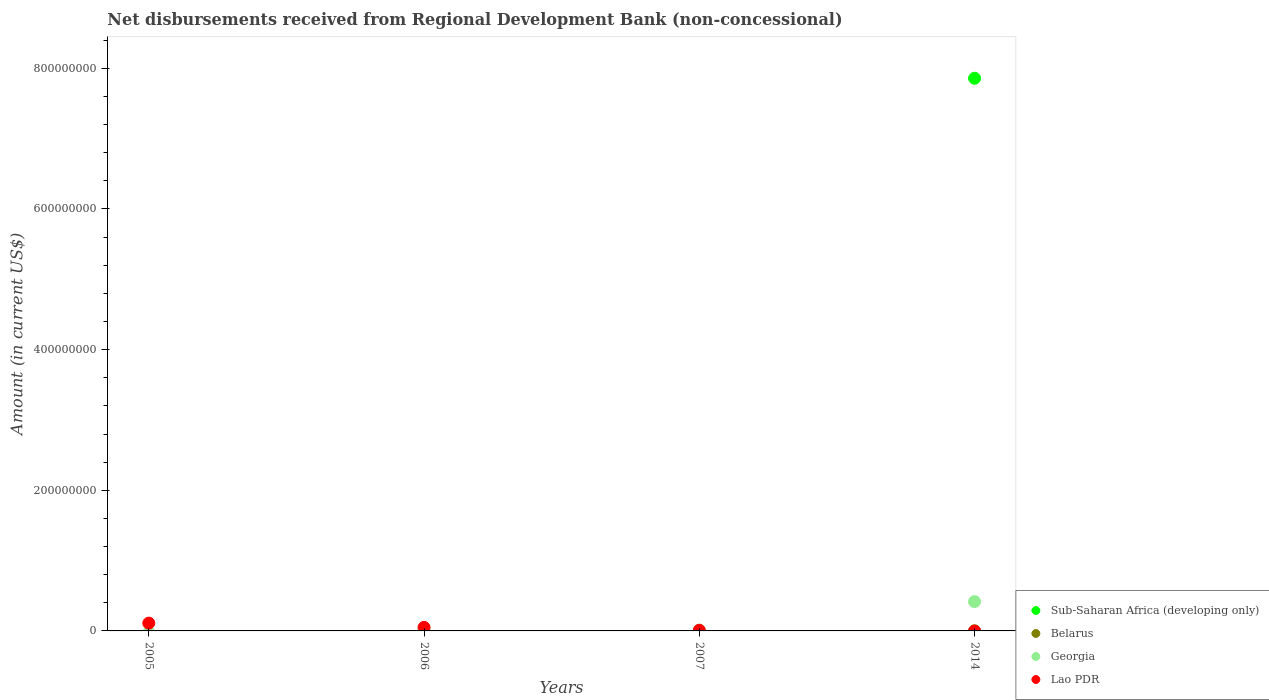How many different coloured dotlines are there?
Provide a succinct answer. 4. Is the number of dotlines equal to the number of legend labels?
Keep it short and to the point. No. What is the amount of disbursements received from Regional Development Bank in Georgia in 2006?
Your answer should be compact. 3.06e+06. Across all years, what is the maximum amount of disbursements received from Regional Development Bank in Sub-Saharan Africa (developing only)?
Your answer should be very brief. 7.86e+08. In which year was the amount of disbursements received from Regional Development Bank in Lao PDR maximum?
Offer a very short reply. 2005. What is the total amount of disbursements received from Regional Development Bank in Georgia in the graph?
Your answer should be very brief. 4.60e+07. What is the difference between the amount of disbursements received from Regional Development Bank in Lao PDR in 2005 and that in 2007?
Your response must be concise. 1.02e+07. What is the difference between the amount of disbursements received from Regional Development Bank in Belarus in 2006 and the amount of disbursements received from Regional Development Bank in Georgia in 2007?
Offer a very short reply. -1.22e+06. What is the average amount of disbursements received from Regional Development Bank in Georgia per year?
Provide a short and direct response. 1.15e+07. In the year 2014, what is the difference between the amount of disbursements received from Regional Development Bank in Georgia and amount of disbursements received from Regional Development Bank in Sub-Saharan Africa (developing only)?
Give a very brief answer. -7.44e+08. In how many years, is the amount of disbursements received from Regional Development Bank in Georgia greater than 480000000 US$?
Offer a terse response. 0. What is the difference between the highest and the second highest amount of disbursements received from Regional Development Bank in Georgia?
Make the answer very short. 3.86e+07. What is the difference between the highest and the lowest amount of disbursements received from Regional Development Bank in Belarus?
Offer a terse response. 2.41e+05. In how many years, is the amount of disbursements received from Regional Development Bank in Georgia greater than the average amount of disbursements received from Regional Development Bank in Georgia taken over all years?
Make the answer very short. 1. Is the sum of the amount of disbursements received from Regional Development Bank in Georgia in 2007 and 2014 greater than the maximum amount of disbursements received from Regional Development Bank in Sub-Saharan Africa (developing only) across all years?
Your answer should be compact. No. Is the amount of disbursements received from Regional Development Bank in Sub-Saharan Africa (developing only) strictly greater than the amount of disbursements received from Regional Development Bank in Lao PDR over the years?
Make the answer very short. No. Is the amount of disbursements received from Regional Development Bank in Lao PDR strictly less than the amount of disbursements received from Regional Development Bank in Georgia over the years?
Provide a short and direct response. No. How many dotlines are there?
Your answer should be very brief. 4. How many years are there in the graph?
Make the answer very short. 4. What is the difference between two consecutive major ticks on the Y-axis?
Your response must be concise. 2.00e+08. Are the values on the major ticks of Y-axis written in scientific E-notation?
Provide a short and direct response. No. Does the graph contain any zero values?
Your answer should be very brief. Yes. What is the title of the graph?
Keep it short and to the point. Net disbursements received from Regional Development Bank (non-concessional). Does "Azerbaijan" appear as one of the legend labels in the graph?
Ensure brevity in your answer.  No. What is the Amount (in current US$) of Sub-Saharan Africa (developing only) in 2005?
Keep it short and to the point. 0. What is the Amount (in current US$) of Belarus in 2005?
Your response must be concise. 0. What is the Amount (in current US$) in Lao PDR in 2005?
Your response must be concise. 1.11e+07. What is the Amount (in current US$) in Georgia in 2006?
Provide a short and direct response. 3.06e+06. What is the Amount (in current US$) of Lao PDR in 2006?
Ensure brevity in your answer.  4.99e+06. What is the Amount (in current US$) of Georgia in 2007?
Offer a terse response. 1.22e+06. What is the Amount (in current US$) of Lao PDR in 2007?
Make the answer very short. 9.09e+05. What is the Amount (in current US$) of Sub-Saharan Africa (developing only) in 2014?
Make the answer very short. 7.86e+08. What is the Amount (in current US$) in Belarus in 2014?
Ensure brevity in your answer.  2.41e+05. What is the Amount (in current US$) in Georgia in 2014?
Your answer should be compact. 4.17e+07. Across all years, what is the maximum Amount (in current US$) of Sub-Saharan Africa (developing only)?
Offer a very short reply. 7.86e+08. Across all years, what is the maximum Amount (in current US$) in Belarus?
Offer a terse response. 2.41e+05. Across all years, what is the maximum Amount (in current US$) in Georgia?
Keep it short and to the point. 4.17e+07. Across all years, what is the maximum Amount (in current US$) in Lao PDR?
Provide a succinct answer. 1.11e+07. Across all years, what is the minimum Amount (in current US$) of Lao PDR?
Your answer should be very brief. 0. What is the total Amount (in current US$) of Sub-Saharan Africa (developing only) in the graph?
Keep it short and to the point. 7.86e+08. What is the total Amount (in current US$) in Belarus in the graph?
Ensure brevity in your answer.  2.41e+05. What is the total Amount (in current US$) of Georgia in the graph?
Your response must be concise. 4.60e+07. What is the total Amount (in current US$) in Lao PDR in the graph?
Give a very brief answer. 1.70e+07. What is the difference between the Amount (in current US$) in Lao PDR in 2005 and that in 2006?
Your answer should be very brief. 6.11e+06. What is the difference between the Amount (in current US$) in Lao PDR in 2005 and that in 2007?
Give a very brief answer. 1.02e+07. What is the difference between the Amount (in current US$) in Georgia in 2006 and that in 2007?
Provide a succinct answer. 1.84e+06. What is the difference between the Amount (in current US$) of Lao PDR in 2006 and that in 2007?
Offer a very short reply. 4.08e+06. What is the difference between the Amount (in current US$) of Georgia in 2006 and that in 2014?
Your answer should be compact. -3.86e+07. What is the difference between the Amount (in current US$) of Georgia in 2007 and that in 2014?
Make the answer very short. -4.05e+07. What is the difference between the Amount (in current US$) in Georgia in 2006 and the Amount (in current US$) in Lao PDR in 2007?
Keep it short and to the point. 2.15e+06. What is the average Amount (in current US$) of Sub-Saharan Africa (developing only) per year?
Offer a very short reply. 1.96e+08. What is the average Amount (in current US$) in Belarus per year?
Provide a succinct answer. 6.02e+04. What is the average Amount (in current US$) of Georgia per year?
Your answer should be compact. 1.15e+07. What is the average Amount (in current US$) in Lao PDR per year?
Your answer should be compact. 4.25e+06. In the year 2006, what is the difference between the Amount (in current US$) of Georgia and Amount (in current US$) of Lao PDR?
Give a very brief answer. -1.93e+06. In the year 2007, what is the difference between the Amount (in current US$) in Georgia and Amount (in current US$) in Lao PDR?
Ensure brevity in your answer.  3.09e+05. In the year 2014, what is the difference between the Amount (in current US$) in Sub-Saharan Africa (developing only) and Amount (in current US$) in Belarus?
Provide a short and direct response. 7.86e+08. In the year 2014, what is the difference between the Amount (in current US$) of Sub-Saharan Africa (developing only) and Amount (in current US$) of Georgia?
Ensure brevity in your answer.  7.44e+08. In the year 2014, what is the difference between the Amount (in current US$) in Belarus and Amount (in current US$) in Georgia?
Your response must be concise. -4.15e+07. What is the ratio of the Amount (in current US$) of Lao PDR in 2005 to that in 2006?
Keep it short and to the point. 2.23. What is the ratio of the Amount (in current US$) of Lao PDR in 2005 to that in 2007?
Offer a terse response. 12.21. What is the ratio of the Amount (in current US$) in Georgia in 2006 to that in 2007?
Offer a terse response. 2.51. What is the ratio of the Amount (in current US$) in Lao PDR in 2006 to that in 2007?
Offer a terse response. 5.49. What is the ratio of the Amount (in current US$) of Georgia in 2006 to that in 2014?
Give a very brief answer. 0.07. What is the ratio of the Amount (in current US$) of Georgia in 2007 to that in 2014?
Offer a very short reply. 0.03. What is the difference between the highest and the second highest Amount (in current US$) in Georgia?
Offer a terse response. 3.86e+07. What is the difference between the highest and the second highest Amount (in current US$) of Lao PDR?
Make the answer very short. 6.11e+06. What is the difference between the highest and the lowest Amount (in current US$) of Sub-Saharan Africa (developing only)?
Ensure brevity in your answer.  7.86e+08. What is the difference between the highest and the lowest Amount (in current US$) of Belarus?
Keep it short and to the point. 2.41e+05. What is the difference between the highest and the lowest Amount (in current US$) in Georgia?
Ensure brevity in your answer.  4.17e+07. What is the difference between the highest and the lowest Amount (in current US$) in Lao PDR?
Your answer should be compact. 1.11e+07. 